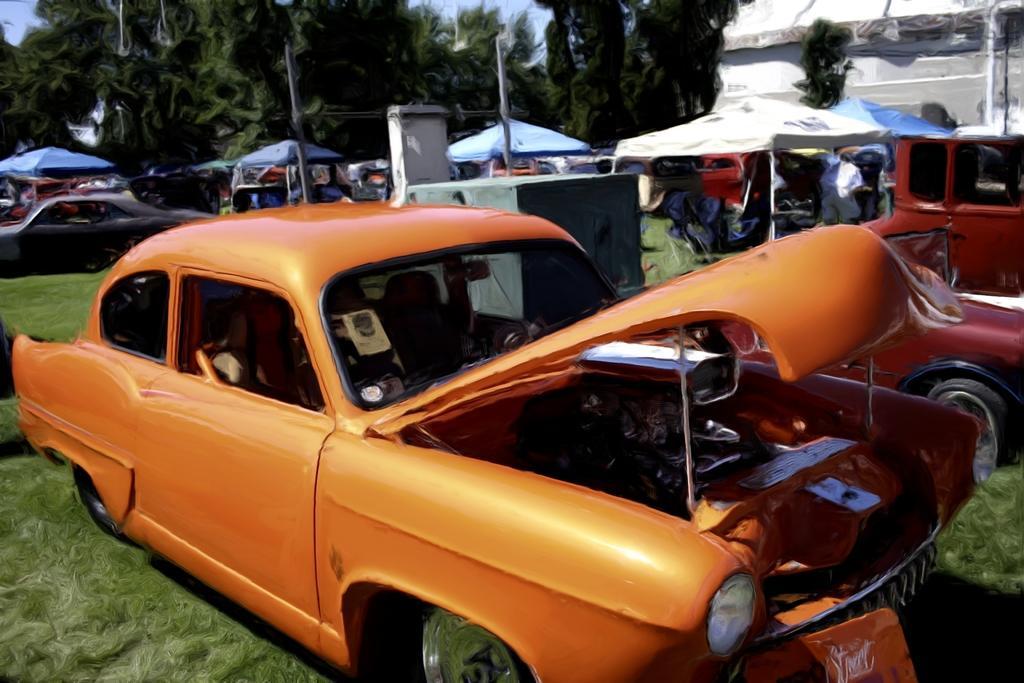In one or two sentences, can you explain what this image depicts? In this image I can see few vehicles, in front the vehicle is in orange color. Background I can see few tents in white color, trees in green color and sky in blue color. 